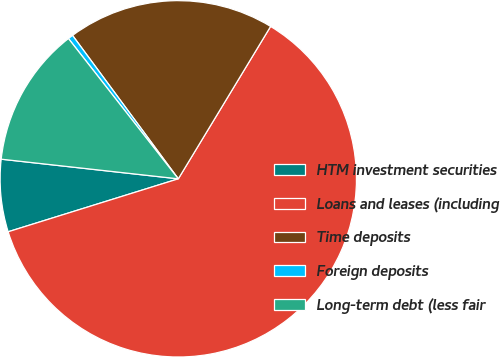<chart> <loc_0><loc_0><loc_500><loc_500><pie_chart><fcel>HTM investment securities<fcel>Loans and leases (including<fcel>Time deposits<fcel>Foreign deposits<fcel>Long-term debt (less fair<nl><fcel>6.56%<fcel>61.53%<fcel>18.78%<fcel>0.46%<fcel>12.67%<nl></chart> 